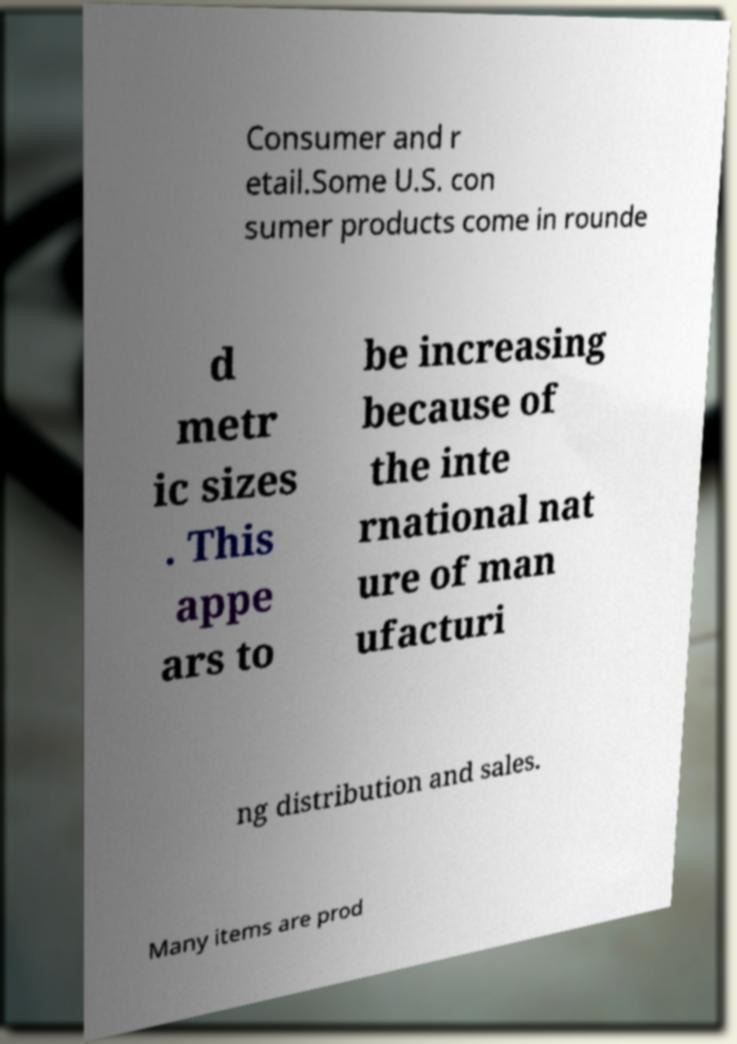Could you assist in decoding the text presented in this image and type it out clearly? Consumer and r etail.Some U.S. con sumer products come in rounde d metr ic sizes . This appe ars to be increasing because of the inte rnational nat ure of man ufacturi ng distribution and sales. Many items are prod 